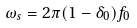<formula> <loc_0><loc_0><loc_500><loc_500>\omega _ { s } = 2 \pi ( 1 - \delta _ { 0 } ) f _ { 0 }</formula> 